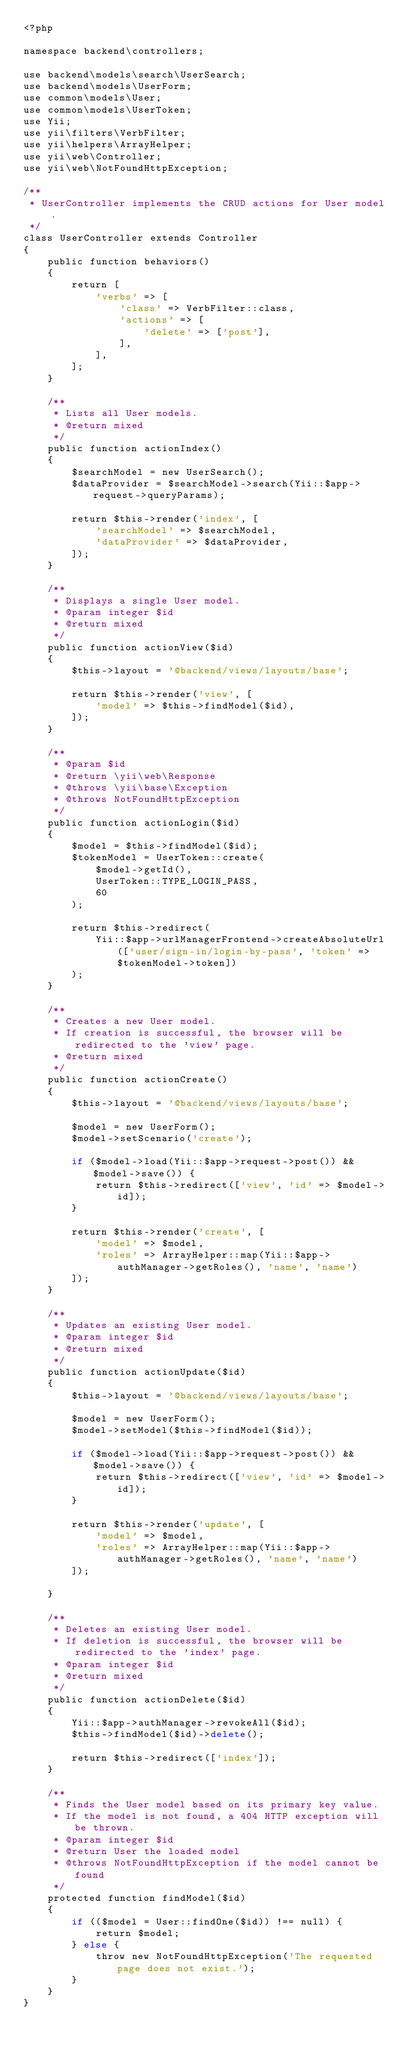<code> <loc_0><loc_0><loc_500><loc_500><_PHP_><?php

namespace backend\controllers;

use backend\models\search\UserSearch;
use backend\models\UserForm;
use common\models\User;
use common\models\UserToken;
use Yii;
use yii\filters\VerbFilter;
use yii\helpers\ArrayHelper;
use yii\web\Controller;
use yii\web\NotFoundHttpException;

/**
 * UserController implements the CRUD actions for User model.
 */
class UserController extends Controller
{
    public function behaviors()
    {
        return [
            'verbs' => [
                'class' => VerbFilter::class,
                'actions' => [
                    'delete' => ['post'],
                ],
            ],
        ];
    }

    /**
     * Lists all User models.
     * @return mixed
     */
    public function actionIndex()
    {
        $searchModel = new UserSearch();
        $dataProvider = $searchModel->search(Yii::$app->request->queryParams);

        return $this->render('index', [
            'searchModel' => $searchModel,
            'dataProvider' => $dataProvider,
        ]);
    }

    /**
     * Displays a single User model.
     * @param integer $id
     * @return mixed
     */
    public function actionView($id)
    {
        $this->layout = '@backend/views/layouts/base';

        return $this->render('view', [
            'model' => $this->findModel($id),
        ]);
    }

    /**
     * @param $id
     * @return \yii\web\Response
     * @throws \yii\base\Exception
     * @throws NotFoundHttpException
     */
    public function actionLogin($id)
    {
        $model = $this->findModel($id);
        $tokenModel = UserToken::create(
            $model->getId(),
            UserToken::TYPE_LOGIN_PASS,
            60
        );

        return $this->redirect(
            Yii::$app->urlManagerFrontend->createAbsoluteUrl(['user/sign-in/login-by-pass', 'token' => $tokenModel->token])
        );
    }

    /**
     * Creates a new User model.
     * If creation is successful, the browser will be redirected to the 'view' page.
     * @return mixed
     */
    public function actionCreate()
    {
        $this->layout = '@backend/views/layouts/base';

        $model = new UserForm();
        $model->setScenario('create');

        if ($model->load(Yii::$app->request->post()) && $model->save()) {
            return $this->redirect(['view', 'id' => $model->id]);
        }

        return $this->render('create', [
            'model' => $model,
            'roles' => ArrayHelper::map(Yii::$app->authManager->getRoles(), 'name', 'name')
        ]);
    }

    /**
     * Updates an existing User model.
     * @param integer $id
     * @return mixed
     */
    public function actionUpdate($id)
    {
        $this->layout = '@backend/views/layouts/base';

        $model = new UserForm();
        $model->setModel($this->findModel($id));
        
        if ($model->load(Yii::$app->request->post()) && $model->save()) {
            return $this->redirect(['view', 'id' => $model->id]);
        }

        return $this->render('update', [
            'model' => $model,
            'roles' => ArrayHelper::map(Yii::$app->authManager->getRoles(), 'name', 'name')
        ]);

    }

    /**
     * Deletes an existing User model.
     * If deletion is successful, the browser will be redirected to the 'index' page.
     * @param integer $id
     * @return mixed
     */
    public function actionDelete($id)
    {
        Yii::$app->authManager->revokeAll($id);
        $this->findModel($id)->delete();

        return $this->redirect(['index']);
    }

    /**
     * Finds the User model based on its primary key value.
     * If the model is not found, a 404 HTTP exception will be thrown.
     * @param integer $id
     * @return User the loaded model
     * @throws NotFoundHttpException if the model cannot be found
     */
    protected function findModel($id)
    {
        if (($model = User::findOne($id)) !== null) {
            return $model;
        } else {
            throw new NotFoundHttpException('The requested page does not exist.');
        }
    }
}
</code> 